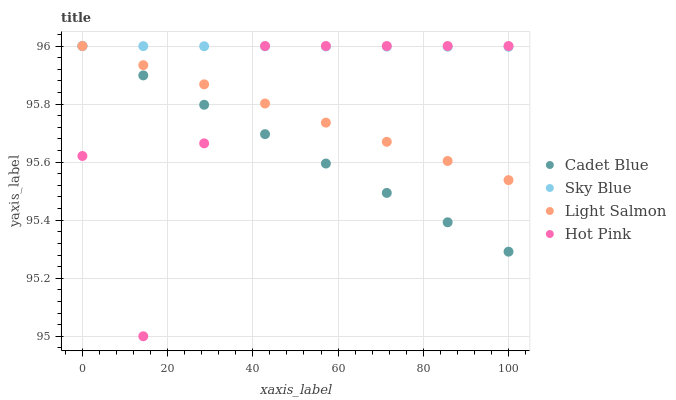Does Cadet Blue have the minimum area under the curve?
Answer yes or no. Yes. Does Sky Blue have the maximum area under the curve?
Answer yes or no. Yes. Does Light Salmon have the minimum area under the curve?
Answer yes or no. No. Does Light Salmon have the maximum area under the curve?
Answer yes or no. No. Is Light Salmon the smoothest?
Answer yes or no. Yes. Is Hot Pink the roughest?
Answer yes or no. Yes. Is Cadet Blue the smoothest?
Answer yes or no. No. Is Cadet Blue the roughest?
Answer yes or no. No. Does Hot Pink have the lowest value?
Answer yes or no. Yes. Does Light Salmon have the lowest value?
Answer yes or no. No. Does Hot Pink have the highest value?
Answer yes or no. Yes. Does Hot Pink intersect Cadet Blue?
Answer yes or no. Yes. Is Hot Pink less than Cadet Blue?
Answer yes or no. No. Is Hot Pink greater than Cadet Blue?
Answer yes or no. No. 